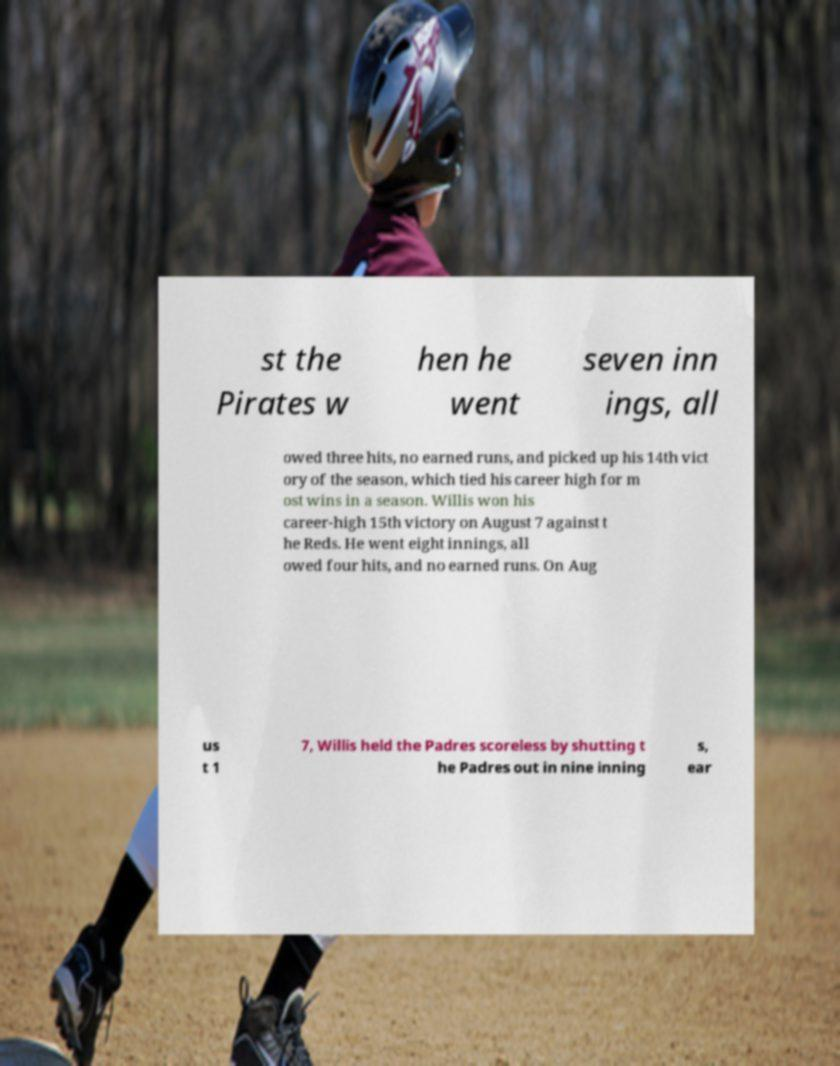Could you assist in decoding the text presented in this image and type it out clearly? st the Pirates w hen he went seven inn ings, all owed three hits, no earned runs, and picked up his 14th vict ory of the season, which tied his career high for m ost wins in a season. Willis won his career-high 15th victory on August 7 against t he Reds. He went eight innings, all owed four hits, and no earned runs. On Aug us t 1 7, Willis held the Padres scoreless by shutting t he Padres out in nine inning s, ear 